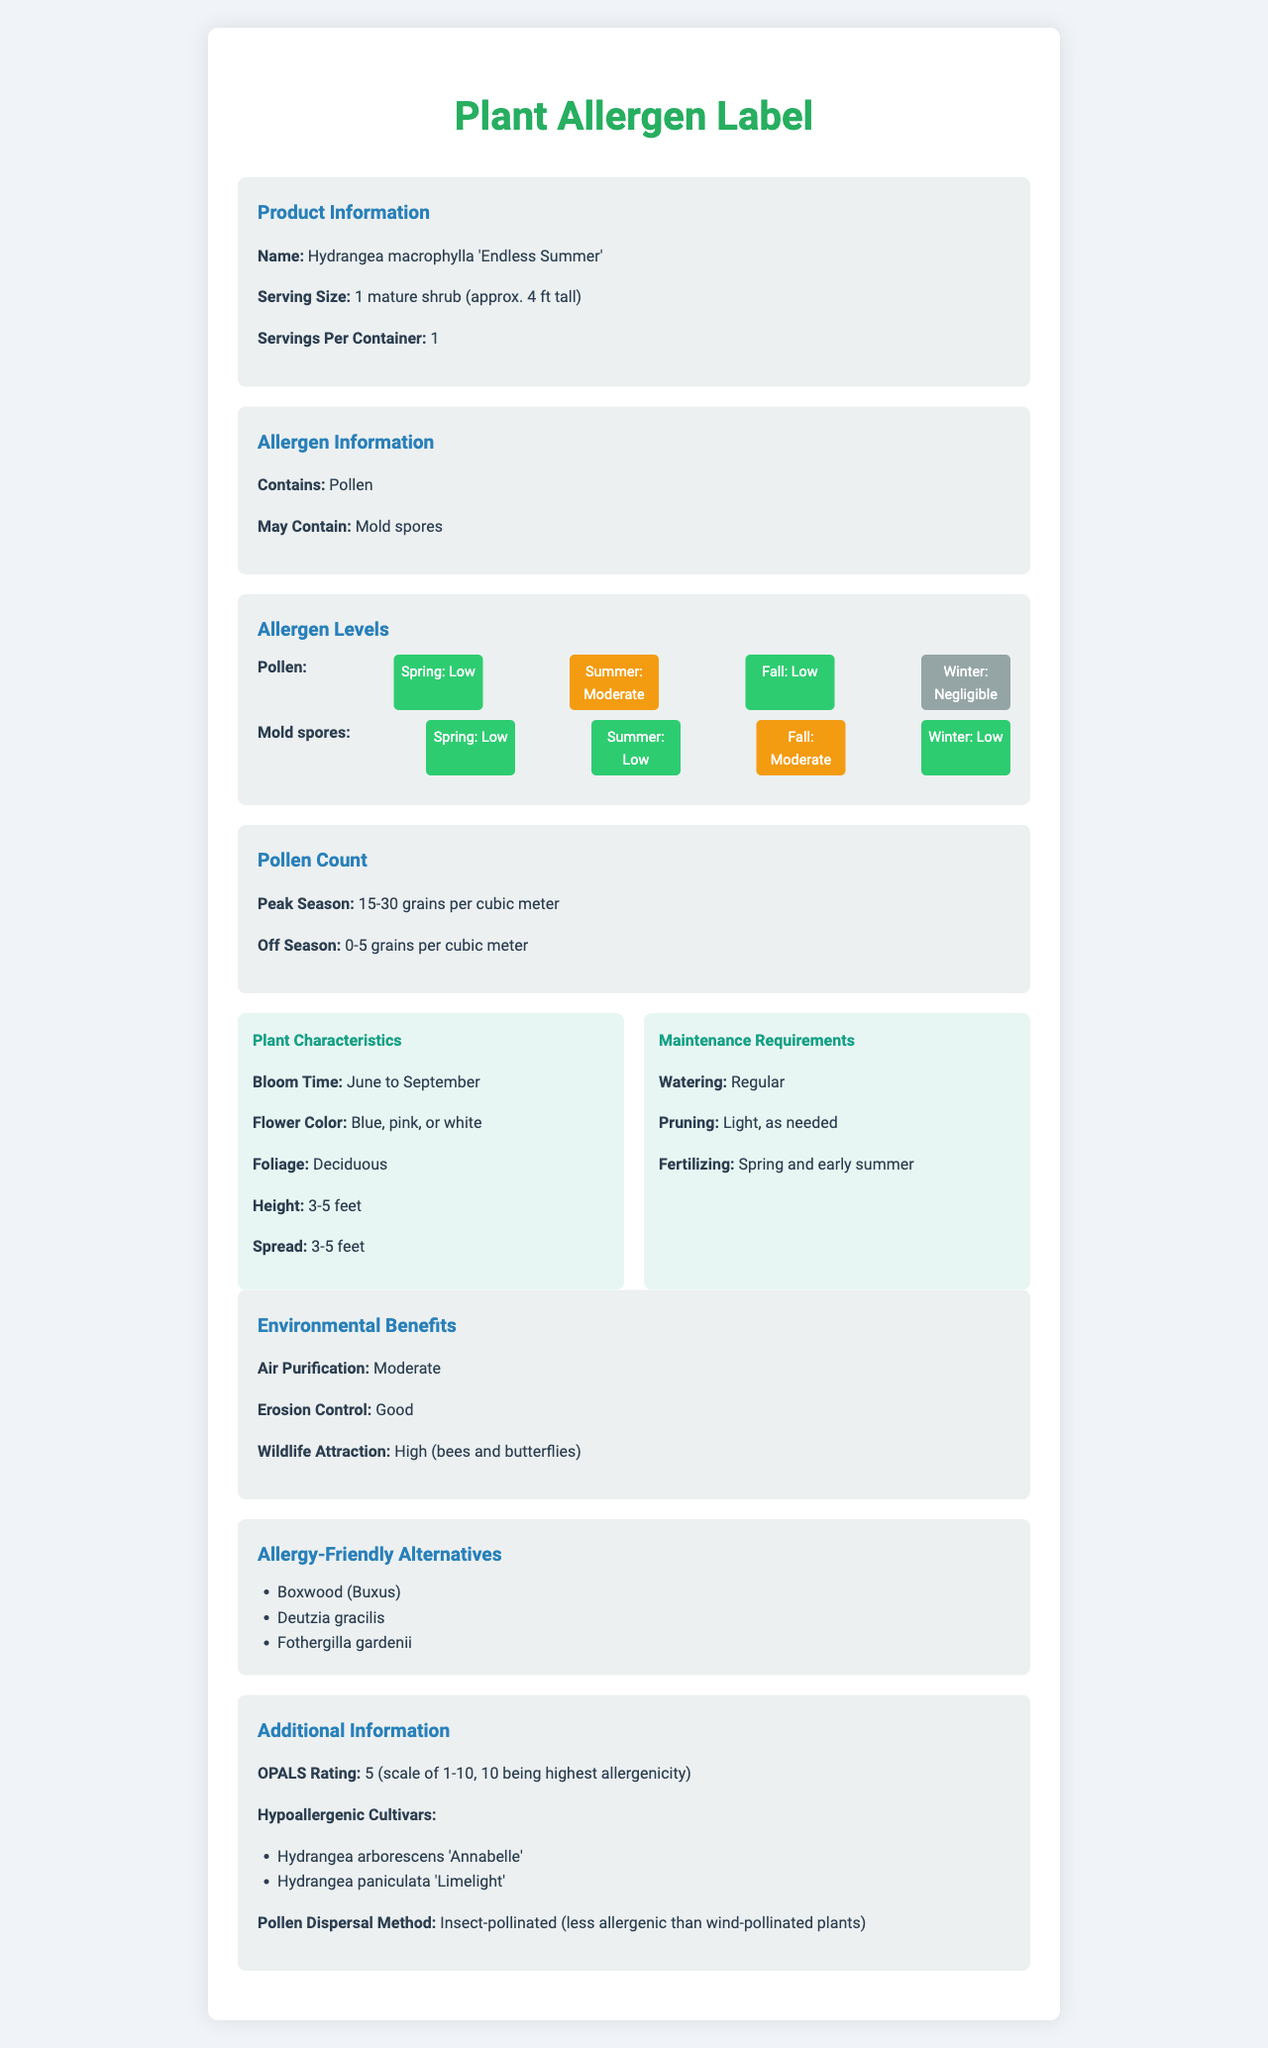what allergens are present in Hydrangea macrophylla 'Endless Summer'? The allergen information section of the document states that the plant contains pollen and may contain mold spores.
Answer: Pollen, Mold spores what is the allergen level for pollen during summer? The allergen level section shows that the pollen level is moderate in the summer.
Answer: Moderate how many grains per cubic meter is the pollen count during the peak season? The pollen count section specifies that during the peak season, the pollen count is between 15 and 30 grains per cubic meter.
Answer: 15-30 grains per cubic meter what are the maintenance requirements for Hydrangea macrophylla 'Endless Summer'? The maintenance requirements section outlines that the plant requires regular watering, light pruning as needed, and fertilizing in spring and early summer.
Answer: Regular watering, Light pruning as needed, Fertilizing in spring and early summer during which months does Hydrangea macrophylla 'Endless Summer' bloom? The plant characteristics section mentions that the bloom time for Hydrangea macrophylla 'Endless Summer' is from June to September.
Answer: June to September which of the following is NOT an environmental benefit mentioned for Hydrangea macrophylla 'Endless Summer'? A. Air purification B. Erosion control C. Noise reduction D. Wildlife attraction The environmental benefits section lists air purification, erosion control, and wildlife attraction but does not mention noise reduction.
Answer: C. Noise reduction what is the OPALS rating of Hydrangea macrophylla 'Endless Summer'? A. 2 B. 5 C. 7 D. 10 The additional information section states the OPALS rating of the plant is 5.
Answer: B. 5 does Hydrangea macrophylla 'Endless Summer' have a high allergenic potential when ingested? The allergenic potential section shows that ingestion is not applicable which means it does not have any allergenic potential when ingested.
Answer: Not applicable is the pollen dispersal for Hydrangea macrophylla 'Endless Summer' primarily insect-pollinated? The additional information section mentions that the pollen dispersal method is insect-pollinated.
Answer: Yes can you determine if Hydrangea macrophylla 'Endless Summer' attracts more wildlife than other hydrangeas? The document provides information about wildlife attraction for Hydrangea macrophylla 'Endless Summer' but does not offer a comparison with other hydrangeas.
Answer: Cannot be determined summarize the key attributes and allergen information for Hydrangea macrophylla 'Endless Summer'. This summary covers the key attributes such as growth, bloom time, and flower and foliage details, maintenance requirements, environmental benefits, allergen levels for pollen and mold spores per season, and other important allergenic and additional information provided in the document.
Answer: Hydrangea macrophylla 'Endless Summer' is a deciduous flowering shrub with bloom time from June to September, coming in colors blue, pink, or white. It grows to a height and spread of 3-5 feet. The allergen information indicates it contains pollen and may contain mold spores, with allergen levels varying by season: pollen is low in spring and fall, moderate in summer, and negligible in winter, while mold spores are low in spring, summer, and winter, and moderate in fall. The pollen count peaks at 15-30 grains per cubic meter in peak season. It has a low allergenic potential for skin contact, moderate for inhalation, and ingestion is not applicable. Maintenance includes regular watering, light pruning as needed, and fertilizing in spring and early summer. It offers environmental benefits like moderate air purification, good erosion control, and high wildlife attraction, with alternatives and hypoallergenic cultivars also available. The OPALS rating is 5, and pollen dispersal is insect-pollinated. 